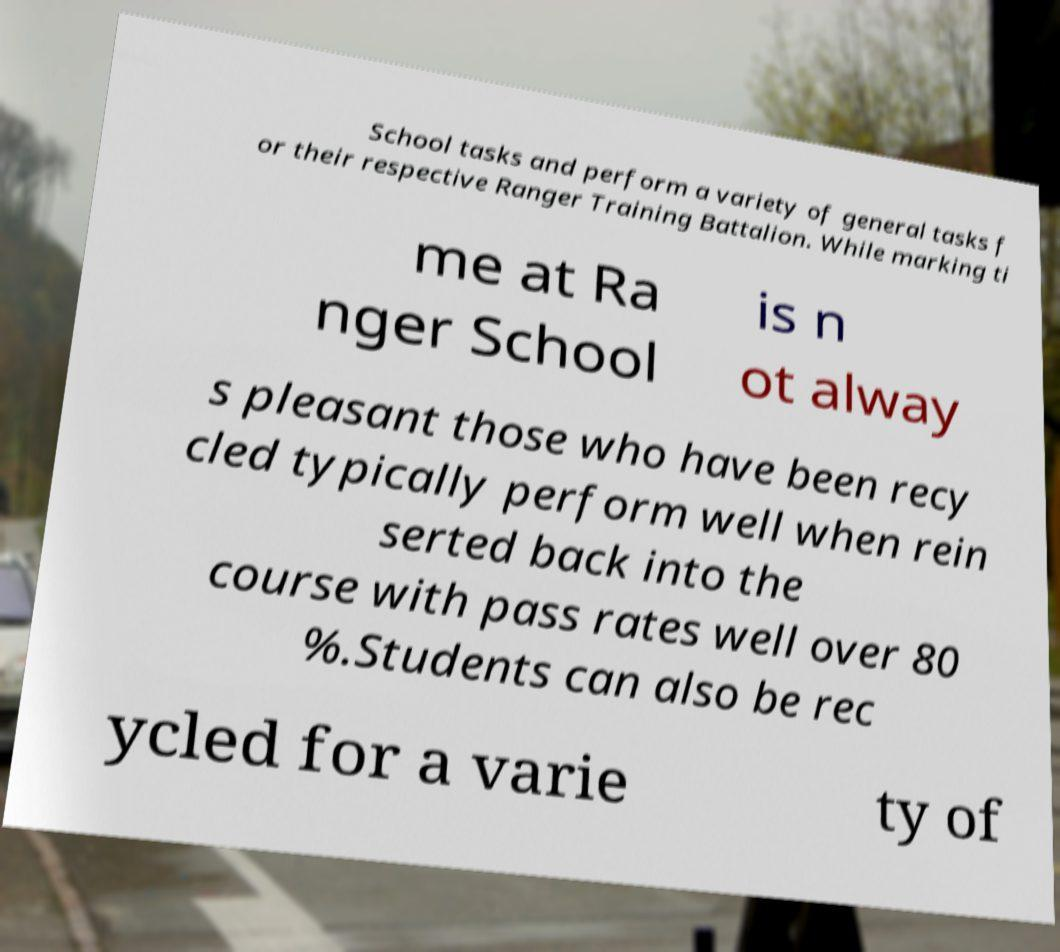Can you accurately transcribe the text from the provided image for me? School tasks and perform a variety of general tasks f or their respective Ranger Training Battalion. While marking ti me at Ra nger School is n ot alway s pleasant those who have been recy cled typically perform well when rein serted back into the course with pass rates well over 80 %.Students can also be rec ycled for a varie ty of 